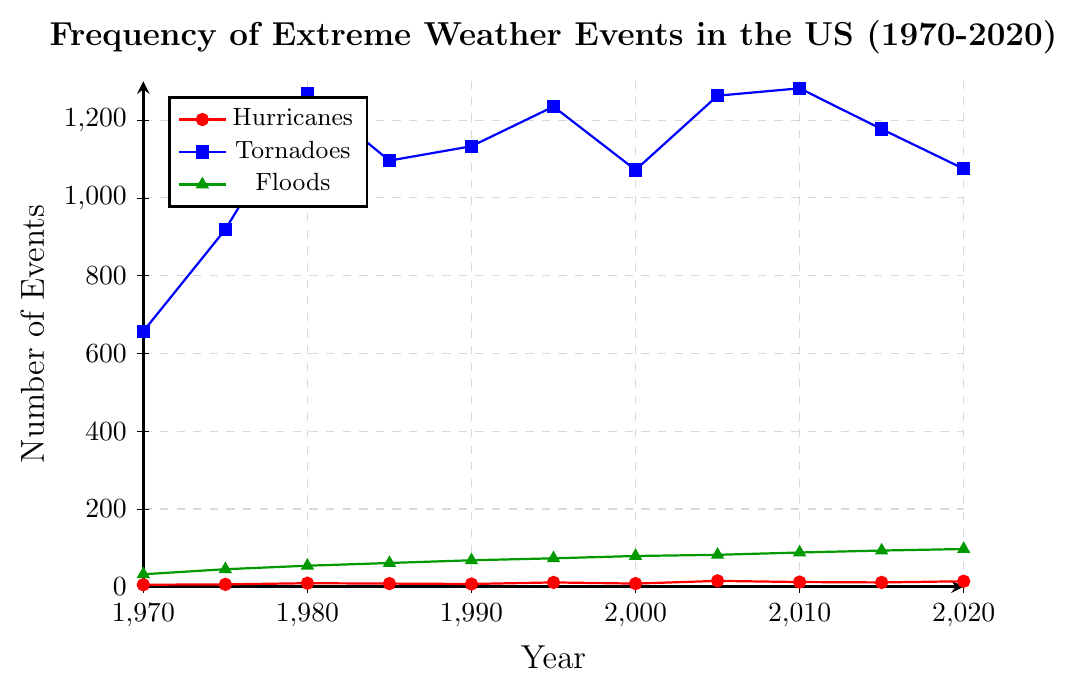What's the trend of hurricane occurrences from 1970 to 2020? To find the trend, observe the data points for hurricanes and connect them visually over the years. The general direction of the line goes from 5 in 1970, peaks at 15 in 2005, and stays relatively high until 2020 with 14.
Answer: Increasing trend Which year had the highest number of tornadoes? Look at the blue line representing tornadoes and identify the highest point on the chart. The highest point is around 1282 in the year 2010.
Answer: 2010 By how much did the frequency of floods increase from 1970 to 2020? Check the green line for floods in 1970 and 2020. The frequency increased from 32 in 1970 to 97 in 2020. Calculate the difference: 97 - 32 = 65.
Answer: 65 Compare the number of hurricanes in 1985 and 2005. Check the red line for hurricanes in 1985 (8) and 2005 (15). 2005 had 7 more hurricanes than 1985: 15 - 8 = 7.
Answer: 7 more hurricanes in 2005 During which decade did tornadoes see the steepest increase? Analyze the blue line between each decade to find the steepest slope. The steepest increase is observed between 1975 (919) and 1980 (1268). Calculate the increase: 1268 - 919 = 349.
Answer: Between 1975 and 1980 Which event shows the most consistent year-over-year increase? By observing all three lines, floods (green line) show a steady increase from 1970 (32) to 2020 (97) with no significant drops.
Answer: Floods In what year did hurricanes, tornadoes, and floods all have an increase compared to the previous recorded year? Inspect each line to find a year where all three metrics increased from the previous recorded year. In 1980, hurricanes went from 6 to 9, tornadoes from 919 to 1268, and floods from 45 to 54.
Answer: 1980 What is the average number of tornadoes per year in the 1990s? Identify the number of tornadoes in each year of the 1990s: 1990 (1133), 1995 (1235), and 2000 (1072). Calculate the average: (1133 + 1235 + 1072) / 3 = 1146.67.
Answer: 1146.67 Do hurricanes or floods have higher variability in their number of occurrences over the given period? By visually comparing the steepness and fluctuations of the red line (hurricanes) and the green line (floods), hurricanes show higher peaks and valleys (more prominent changes) compared to floods, which have a more consistent trend.
Answer: Hurricanes Between which consecutive years did hurricanes decrease the most? Determine where the red line drops the most between two consecutive points. The largest decrease is between 2005 (15) and 2010 (12): 15 - 12 = 3.
Answer: Between 2005 and 2010 